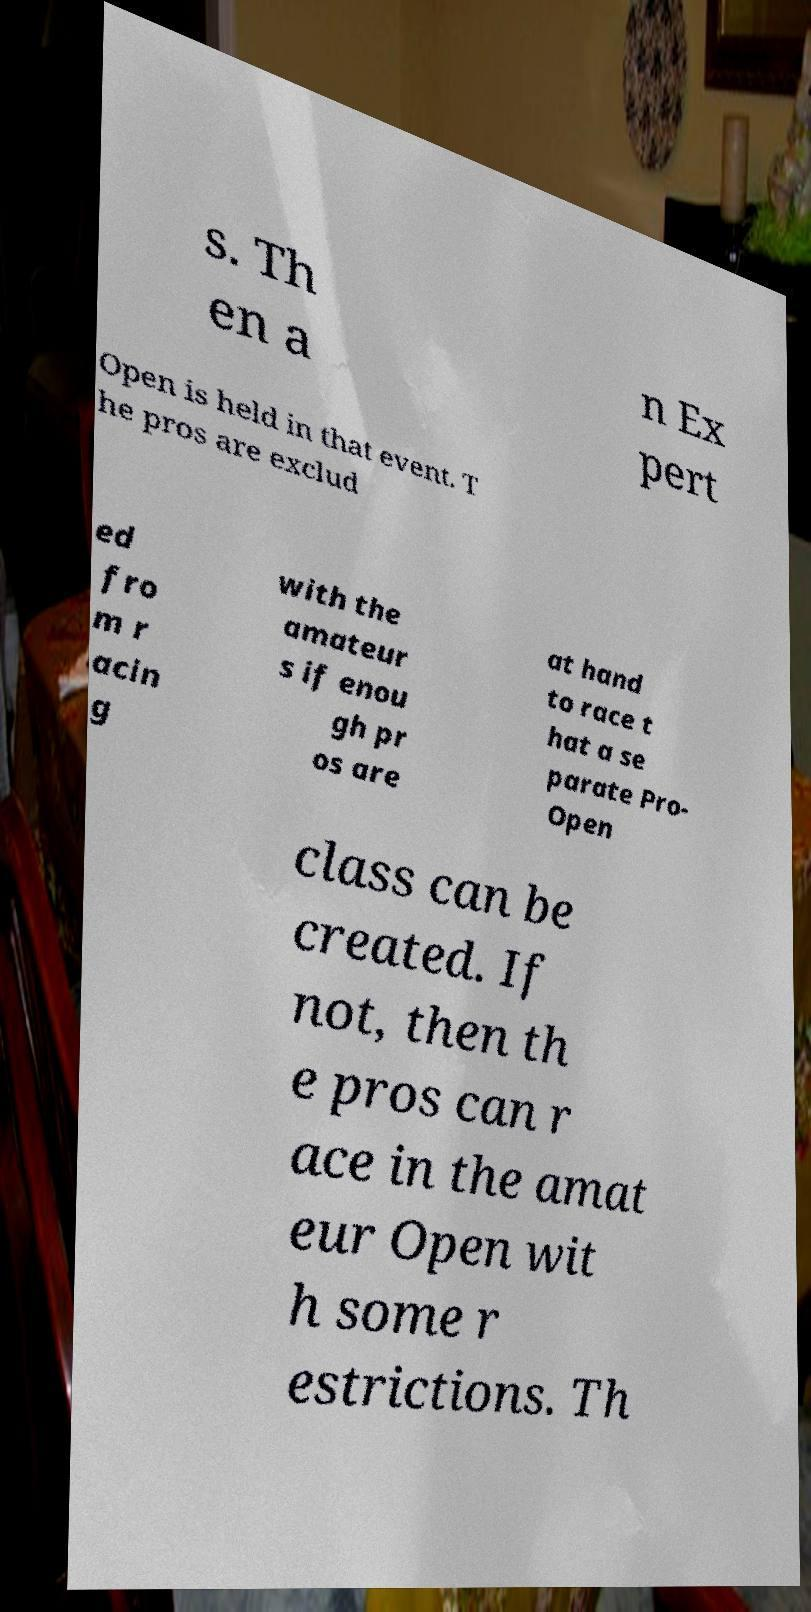Could you assist in decoding the text presented in this image and type it out clearly? s. Th en a n Ex pert Open is held in that event. T he pros are exclud ed fro m r acin g with the amateur s if enou gh pr os are at hand to race t hat a se parate Pro- Open class can be created. If not, then th e pros can r ace in the amat eur Open wit h some r estrictions. Th 